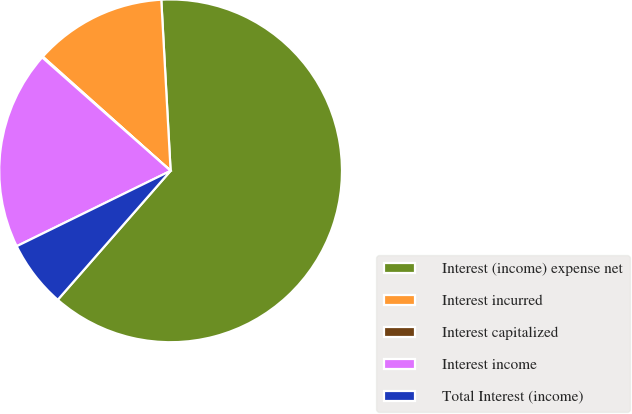Convert chart. <chart><loc_0><loc_0><loc_500><loc_500><pie_chart><fcel>Interest (income) expense net<fcel>Interest incurred<fcel>Interest capitalized<fcel>Interest income<fcel>Total Interest (income)<nl><fcel>62.3%<fcel>12.53%<fcel>0.09%<fcel>18.76%<fcel>6.31%<nl></chart> 